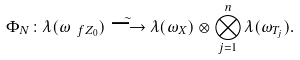Convert formula to latex. <formula><loc_0><loc_0><loc_500><loc_500>\Phi _ { N } \colon \lambda ( \omega _ { \ f Z _ { 0 } } ) \overset { \sim } { \longrightarrow } \lambda ( \omega _ { X } ) \otimes \bigotimes _ { j = 1 } ^ { n } \lambda ( \omega _ { T _ { j } } ) .</formula> 